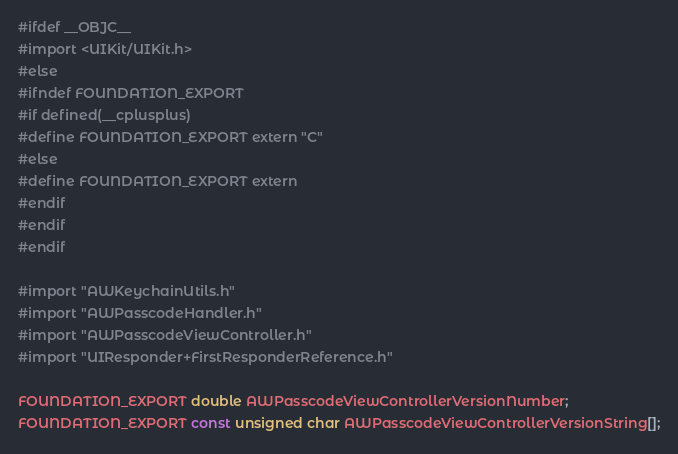<code> <loc_0><loc_0><loc_500><loc_500><_C_>#ifdef __OBJC__
#import <UIKit/UIKit.h>
#else
#ifndef FOUNDATION_EXPORT
#if defined(__cplusplus)
#define FOUNDATION_EXPORT extern "C"
#else
#define FOUNDATION_EXPORT extern
#endif
#endif
#endif

#import "AWKeychainUtils.h"
#import "AWPasscodeHandler.h"
#import "AWPasscodeViewController.h"
#import "UIResponder+FirstResponderReference.h"

FOUNDATION_EXPORT double AWPasscodeViewControllerVersionNumber;
FOUNDATION_EXPORT const unsigned char AWPasscodeViewControllerVersionString[];

</code> 